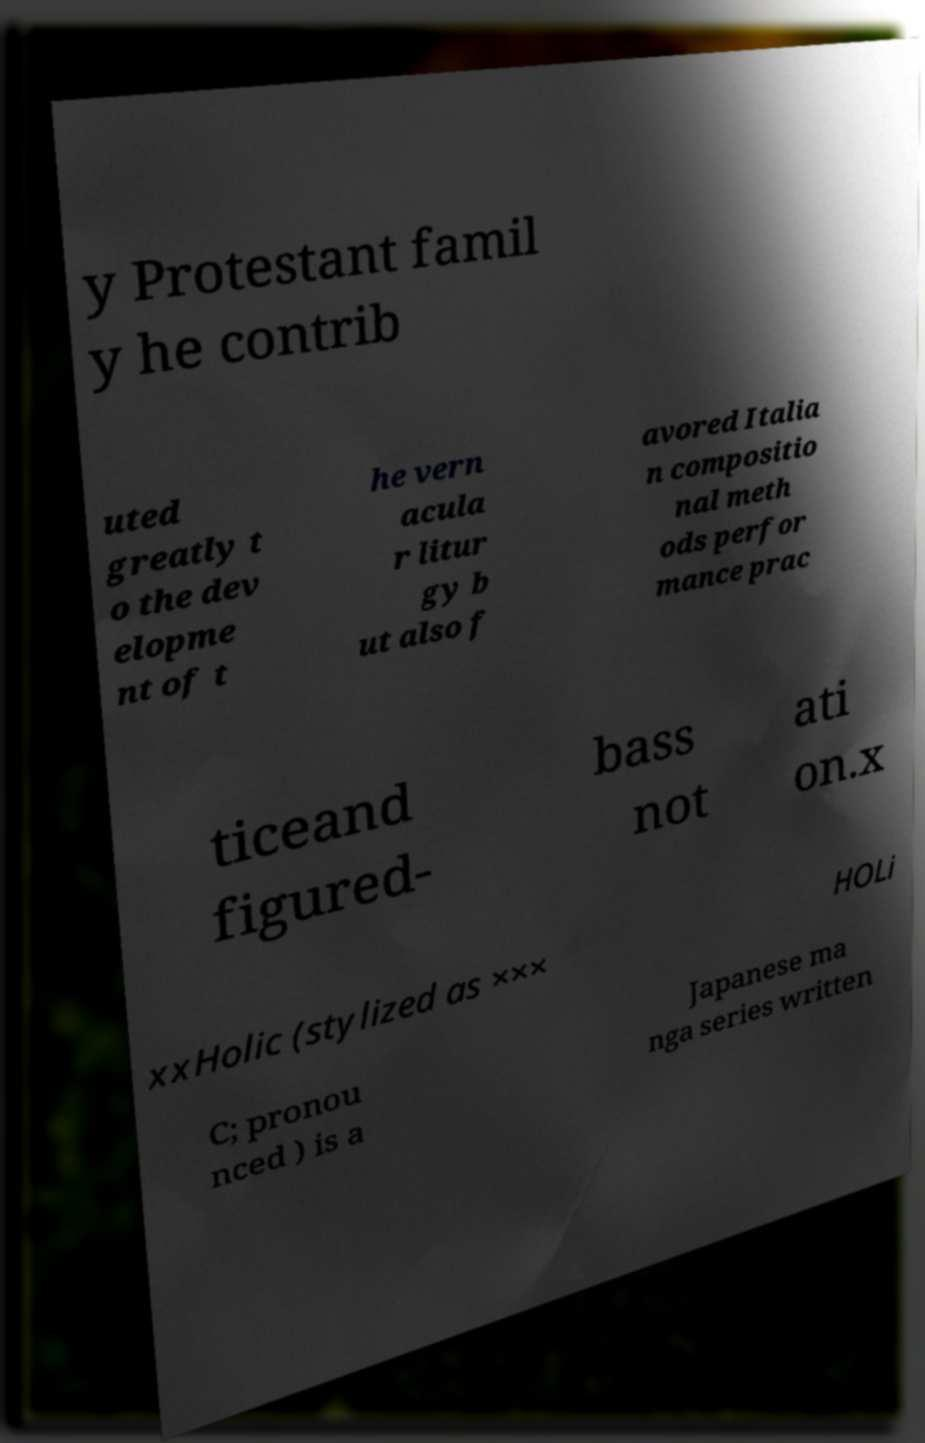What messages or text are displayed in this image? I need them in a readable, typed format. y Protestant famil y he contrib uted greatly t o the dev elopme nt of t he vern acula r litur gy b ut also f avored Italia n compositio nal meth ods perfor mance prac ticeand figured- bass not ati on.x xxHolic (stylized as ××× HOLi C; pronou nced ) is a Japanese ma nga series written 